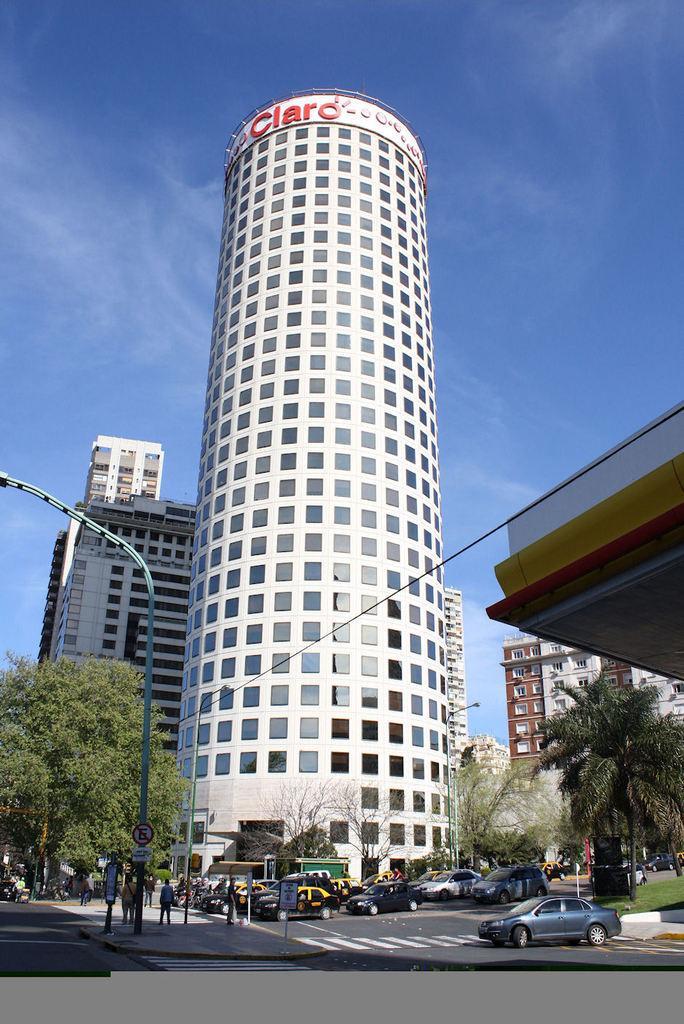Can you describe this image briefly? In this image I can see roads and on it I can see few white lines and few vehicles. I can also see number of buildings, trees, a pole, clouds, the sky and I can see number of people are standing. I can also see something is written over here. 